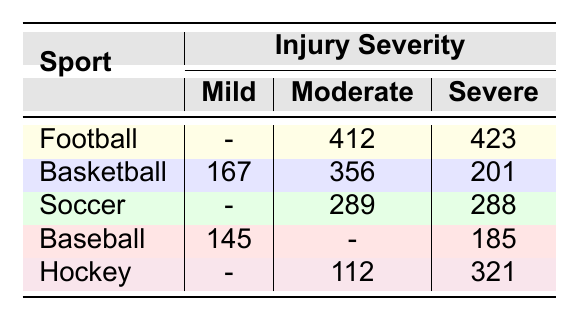What is the total number of severe injuries in Football? To find the total number of severe injuries in Football, we look at the column for severe injuries under the Football row. It lists 423 incidents for severe injuries.
Answer: 423 Which sport has the highest number of moderate injuries? By comparing the moderate injury counts across all sports, Basketball shows 356 moderate injuries, which is the highest amount.
Answer: Basketball Is there any sport that has no mild injuries recorded? Looking through the mild injury column, both Football and Soccer have zeros recorded, indicating no mild injuries.
Answer: Yes What is the total number of injuries (all severities) for Baseball? To determine this, we sum all injury incidents for Baseball: 145 (mild) + 0 (moderate) + 185 (severe) = 330 incidents in total.
Answer: 330 Which sport has the most incidents of ankle sprains, and how many cases were reported? Ankle sprains are represented under Football with 412 incidents and Basketball with 356 incidents. Thus, Football has the most ankle sprains with 412 cases.
Answer: Football, 412 What is the difference between moderate injuries in Hockey and Soccer? The number of moderate injuries in Hockey is 112, and for Soccer, it is 289. The difference between them is calculated as 289 - 112 = 177.
Answer: 177 In total, how many incidents of severe injuries are there across all sports? By adding the severe injuries from each sport: 423 (Football) + 201 (Basketball) + 288 (Soccer) + 185 (Baseball) + 321 (Hockey) gives a sum of 1418 severe injuries in total.
Answer: 1418 Which sport has the second highest number of total injuries (considering all severities)? After summing all injuries per sport, Football has 423 + 412 = 835, Basketball has 167 + 356 + 201 = 724, Soccer has 132 + 156 + 289 = 577, Baseball has 145 + 0 + 185 = 330, and Hockey has 321 + 112 + 0 = 433. Thus, Football has the most injuries and Basketball is second highest with 724.
Answer: Basketball Do severe injuries in Soccer outnumber mild injuries in Baseball? Soccer has 288 severe injuries while Baseball has 145 mild injuries. Since 288 is greater than 145, the statement is true.
Answer: Yes What percentage of total injuries in Basketball are classified as severe? The total injuries in Basketball (167 + 356 + 201 = 724) and the severe injuries (201). The percentage is calculated as (201 / 724) * 100, which results in approximately 27.8%.
Answer: 27.8% 